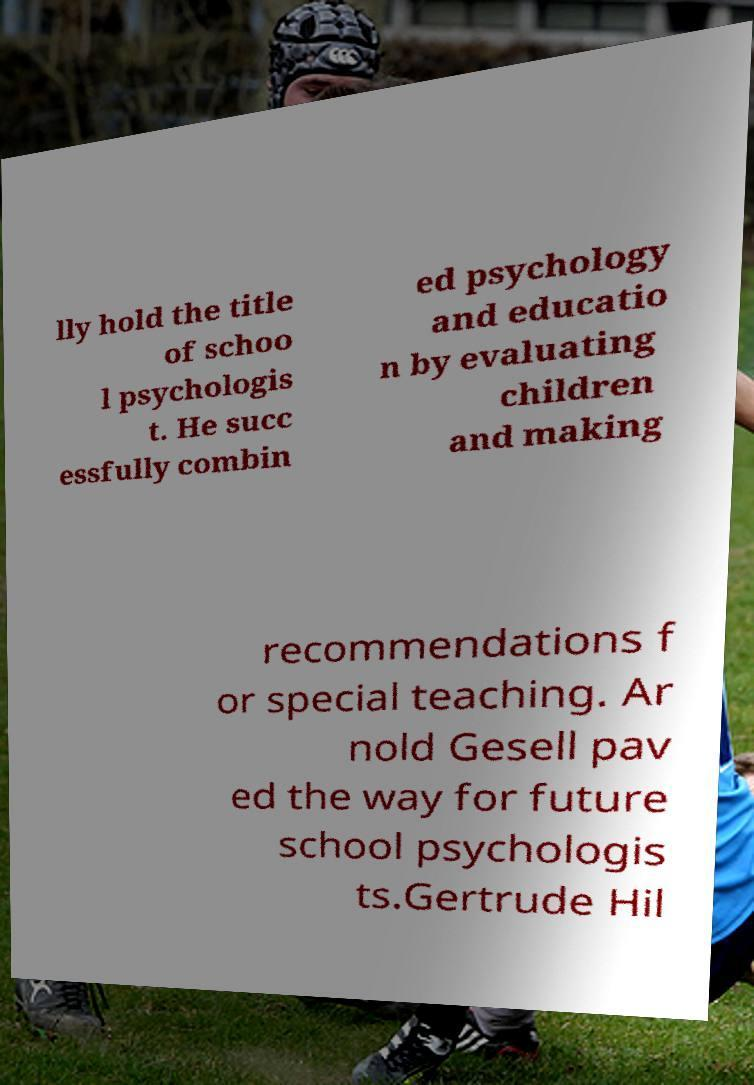For documentation purposes, I need the text within this image transcribed. Could you provide that? lly hold the title of schoo l psychologis t. He succ essfully combin ed psychology and educatio n by evaluating children and making recommendations f or special teaching. Ar nold Gesell pav ed the way for future school psychologis ts.Gertrude Hil 